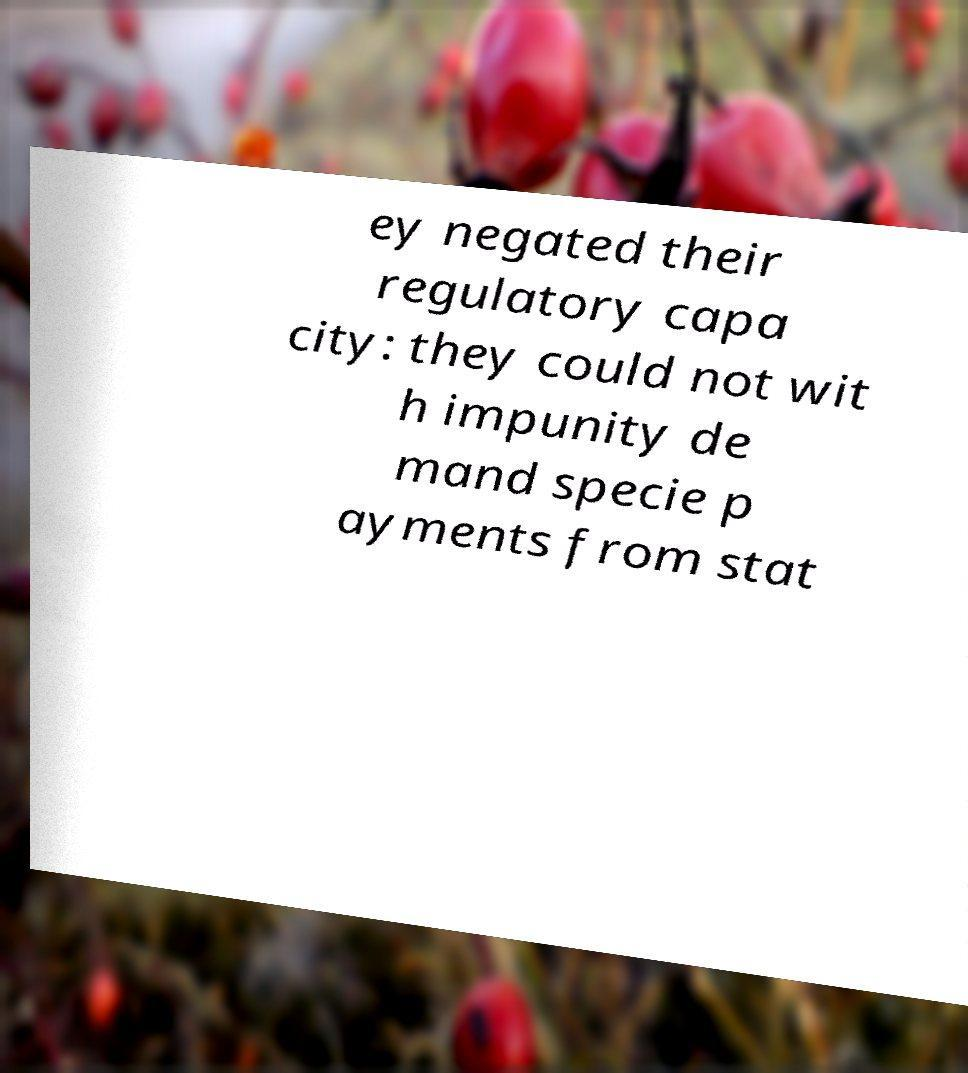For documentation purposes, I need the text within this image transcribed. Could you provide that? ey negated their regulatory capa city: they could not wit h impunity de mand specie p ayments from stat 